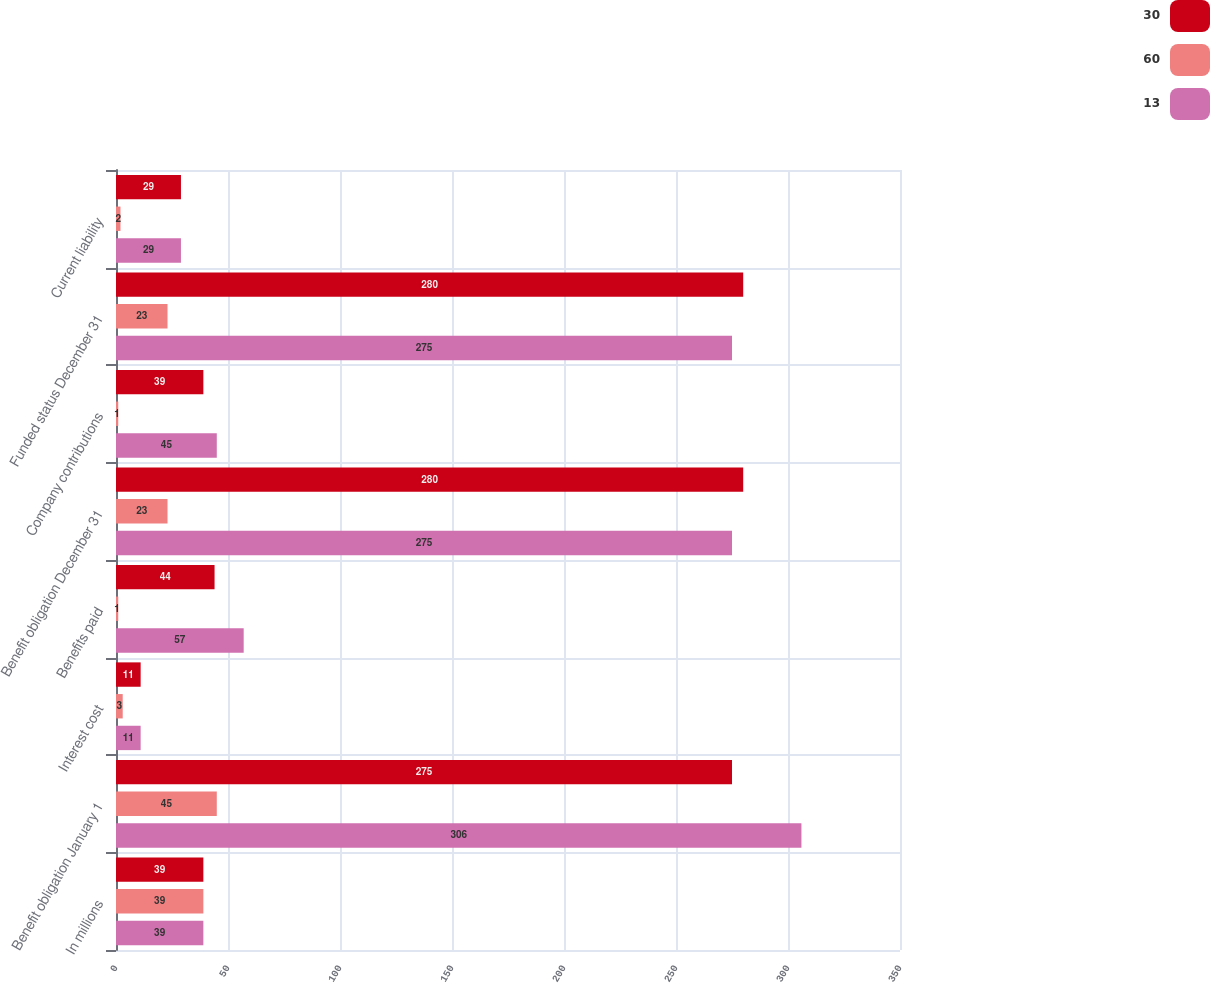Convert chart. <chart><loc_0><loc_0><loc_500><loc_500><stacked_bar_chart><ecel><fcel>In millions<fcel>Benefit obligation January 1<fcel>Interest cost<fcel>Benefits paid<fcel>Benefit obligation December 31<fcel>Company contributions<fcel>Funded status December 31<fcel>Current liability<nl><fcel>30<fcel>39<fcel>275<fcel>11<fcel>44<fcel>280<fcel>39<fcel>280<fcel>29<nl><fcel>60<fcel>39<fcel>45<fcel>3<fcel>1<fcel>23<fcel>1<fcel>23<fcel>2<nl><fcel>13<fcel>39<fcel>306<fcel>11<fcel>57<fcel>275<fcel>45<fcel>275<fcel>29<nl></chart> 